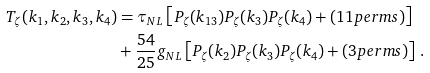Convert formula to latex. <formula><loc_0><loc_0><loc_500><loc_500>T _ { \zeta } ( k _ { 1 } , k _ { 2 } , k _ { 3 } , k _ { 4 } ) & = \tau _ { N L } \left [ P _ { \zeta } ( k _ { 1 3 } ) P _ { \zeta } ( k _ { 3 } ) P _ { \zeta } ( k _ { 4 } ) + ( 1 1 p e r m s ) \right ] \\ & + \frac { 5 4 } { 2 5 } g _ { N L } \left [ P _ { \zeta } ( k _ { 2 } ) P _ { \zeta } ( k _ { 3 } ) P _ { \zeta } ( k _ { 4 } ) + ( 3 p e r m s ) \right ] \, .</formula> 